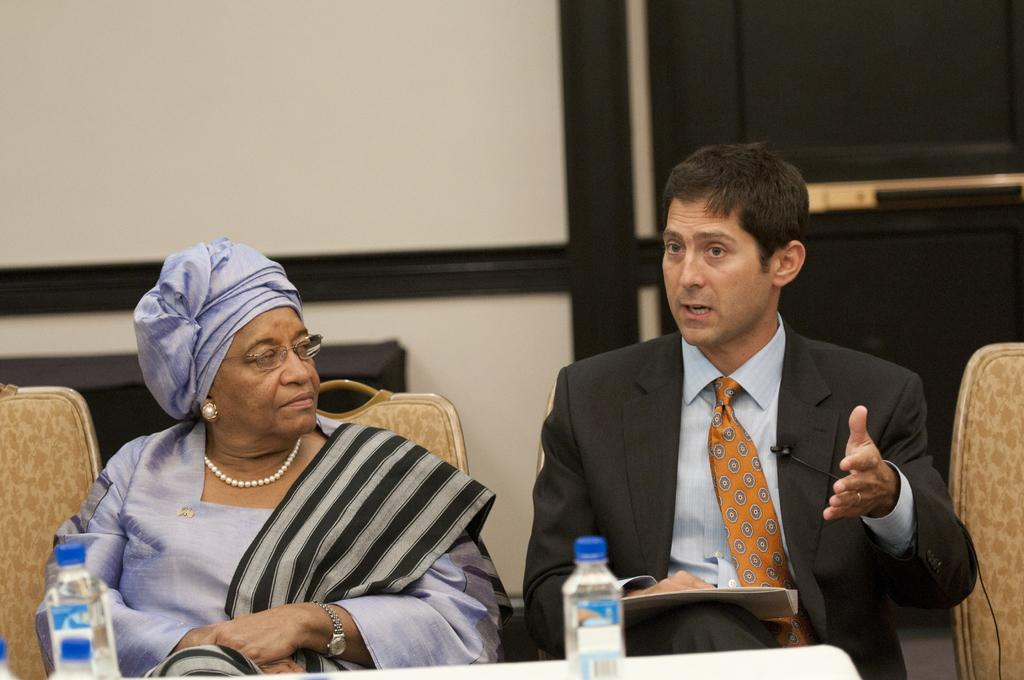What is the man in the image wearing? The man is wearing a black suit. What is the woman in the image wearing? The woman is wearing a blue dress. What are the man and woman doing in the image? The man is sitting and talking, while the woman is sitting. What can be seen in the background of the image? There is a white wall and a black door in the background. What type of pen is the man using to write during his conversation with the woman? There is no pen visible in the image, and the man is not writing during his conversation with the woman. Can you describe the lunch that the woman is eating while sitting in the image? There is no lunch present in the image; the woman is simply sitting. 